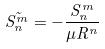<formula> <loc_0><loc_0><loc_500><loc_500>\tilde { S _ { n } ^ { m } } = - \frac { S _ { n } ^ { m } } { \mu R ^ { n } }</formula> 